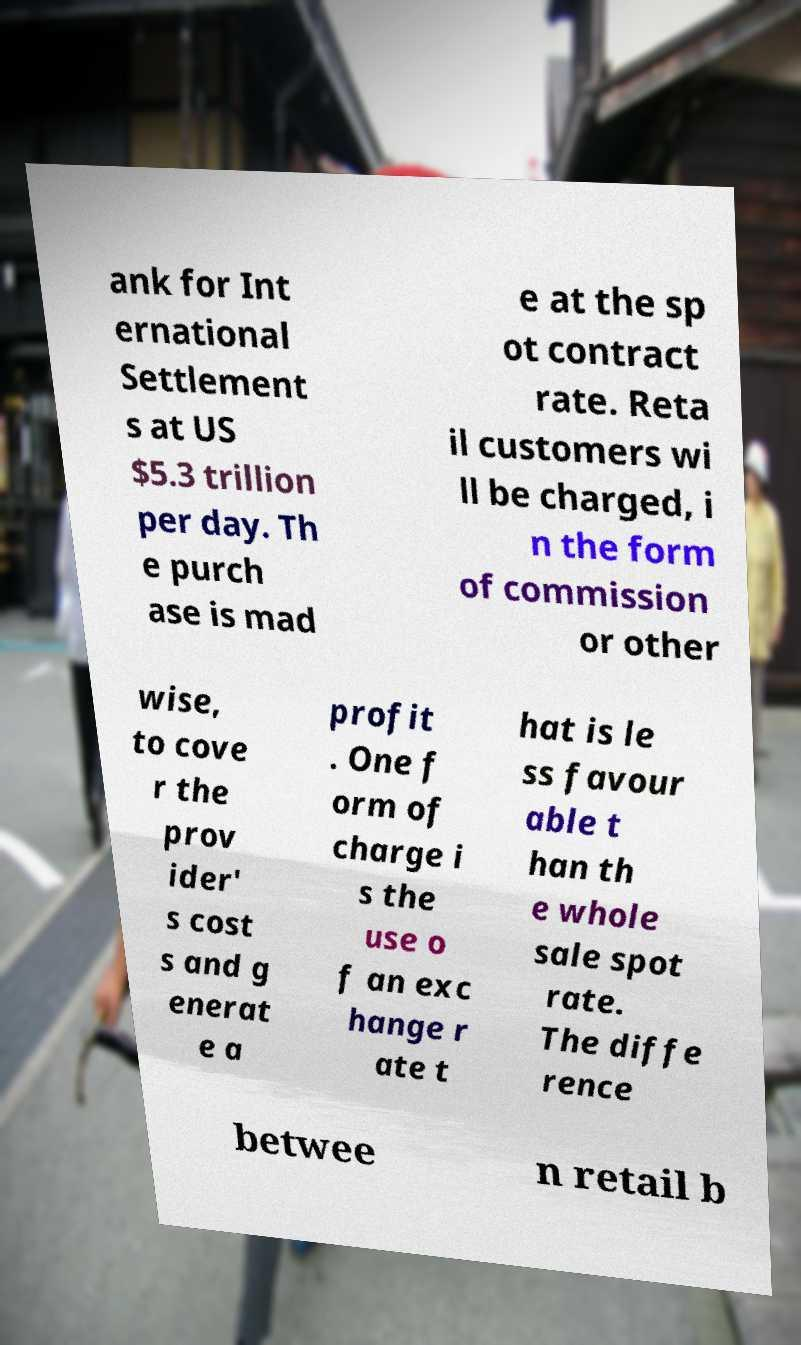I need the written content from this picture converted into text. Can you do that? ank for Int ernational Settlement s at US $5.3 trillion per day. Th e purch ase is mad e at the sp ot contract rate. Reta il customers wi ll be charged, i n the form of commission or other wise, to cove r the prov ider' s cost s and g enerat e a profit . One f orm of charge i s the use o f an exc hange r ate t hat is le ss favour able t han th e whole sale spot rate. The diffe rence betwee n retail b 